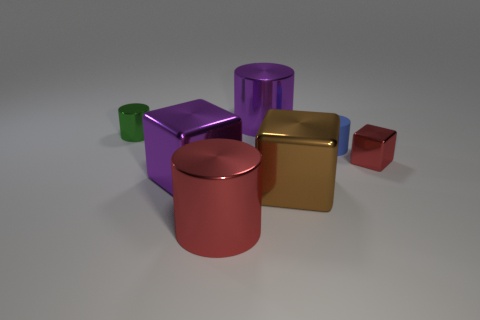Subtract all blue blocks. Subtract all purple spheres. How many blocks are left? 3 Subtract all cyan spheres. How many green cylinders are left? 1 Add 3 large purples. How many tiny things exist? 0 Subtract all large gray shiny cubes. Subtract all big brown shiny blocks. How many objects are left? 6 Add 2 purple cubes. How many purple cubes are left? 3 Add 4 small cyan balls. How many small cyan balls exist? 4 Add 3 cyan shiny cylinders. How many objects exist? 10 Subtract all red blocks. How many blocks are left? 2 Subtract all small blocks. How many blocks are left? 2 Subtract 1 green cylinders. How many objects are left? 6 